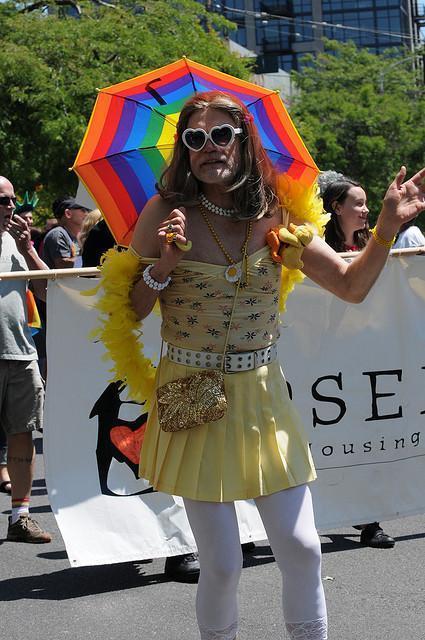How many people are there?
Give a very brief answer. 4. 